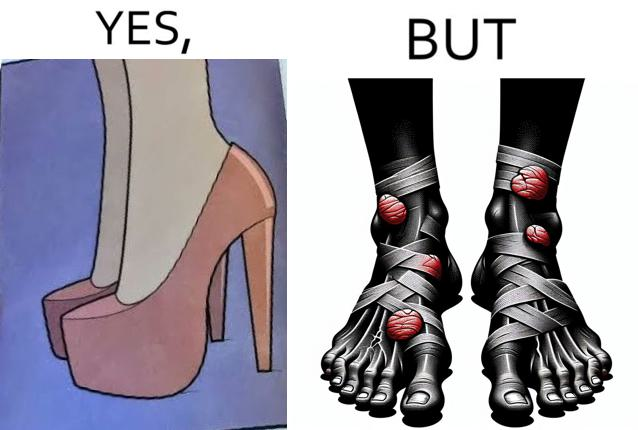What does this image depict? The images are funny since they show how the prettiest footwears like high heels, end up causing a lot of physical discomfort to the user, all in the name fashion 